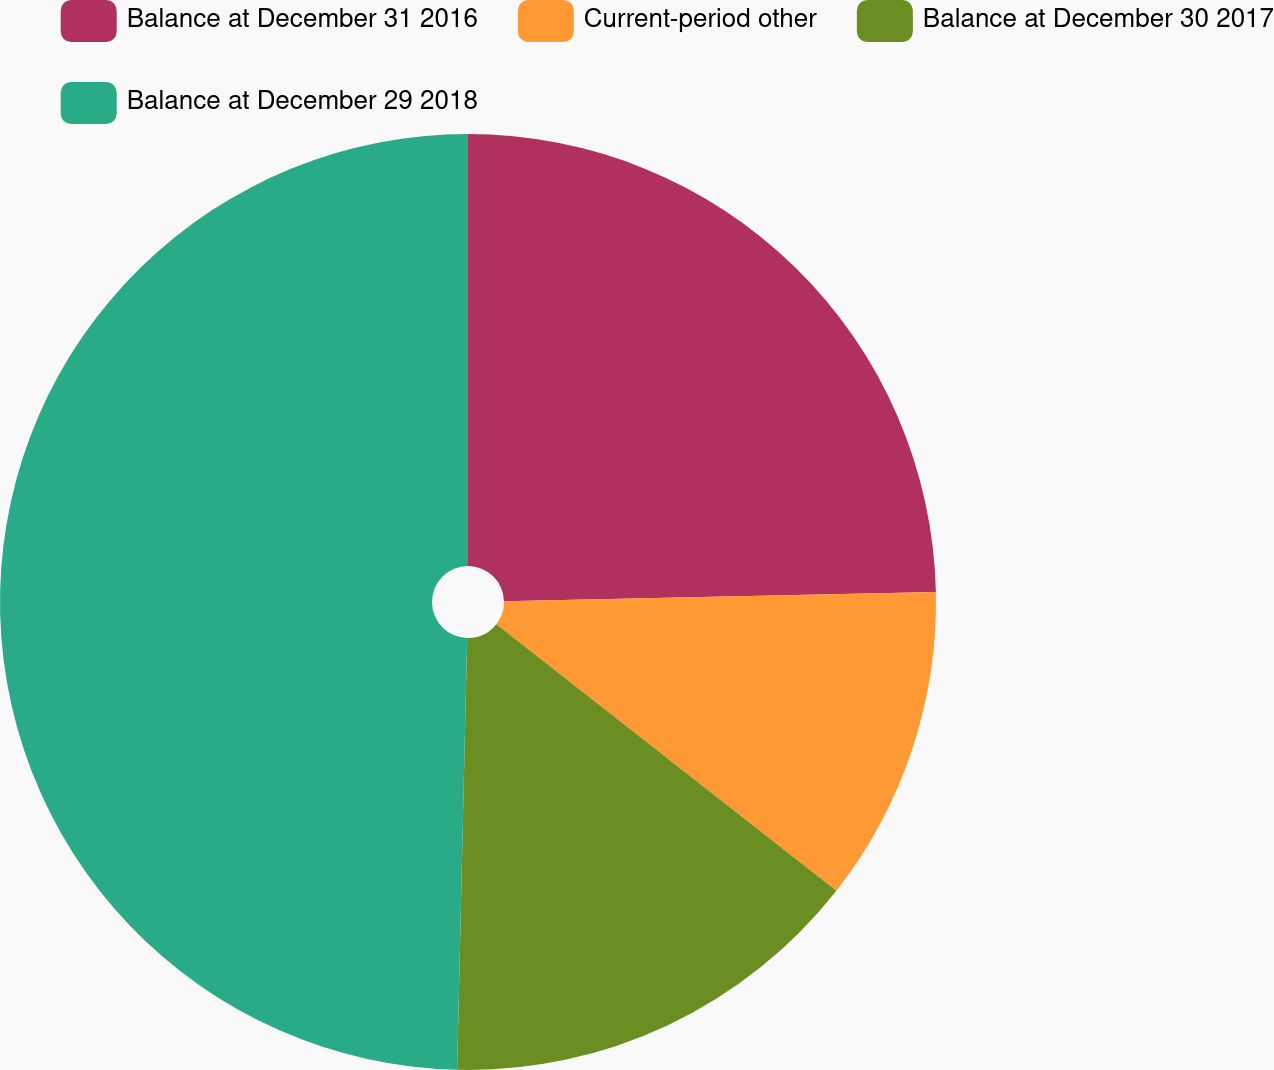<chart> <loc_0><loc_0><loc_500><loc_500><pie_chart><fcel>Balance at December 31 2016<fcel>Current-period other<fcel>Balance at December 30 2017<fcel>Balance at December 29 2018<nl><fcel>24.66%<fcel>10.92%<fcel>14.79%<fcel>49.63%<nl></chart> 